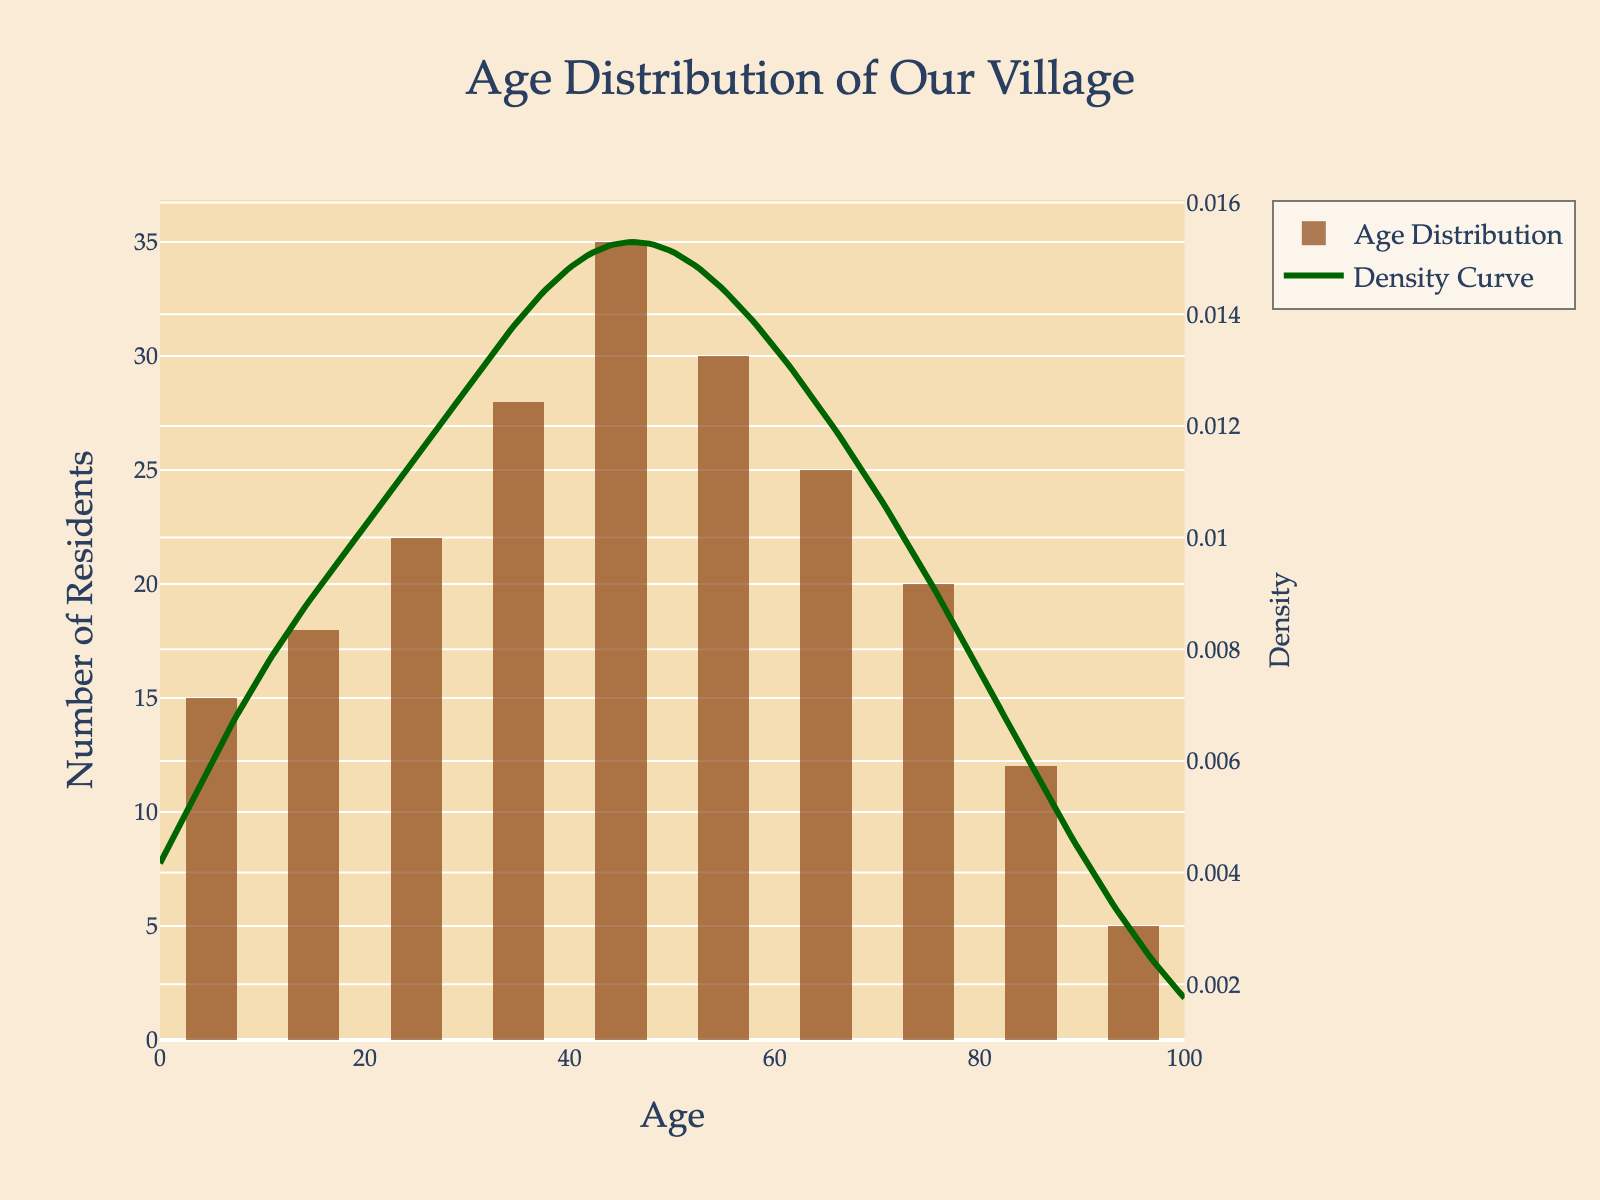what is the title of the plot? The title is prominently displayed at the top of the plot. It reads "Age Distribution of Our Village".
Answer: Age Distribution of Our Village What is the age group with the highest number of residents? The age groups are represented by bars, with the height indicating the count. The 40-49 age group has the tallest bar.
Answer: 40-49 How many residents are there in the 70-79 age group? The bar representing the 70-79 age group reaches the 20-mark on the y-axis, indicating there are 20 residents in this group.
Answer: 20 What is the trend observed from the 0-9 age group to the 40-49 age group? From the histogram, the bars representing the number of residents increase in height from 0-9 to 40-49. This indicates a rising trend or increasing number of residents with age, up to 49.
Answer: Increasing Which age group shows a noticeable decline in the number of residents after 50-59? The bars for age groups 60-69, 70-79, and 80-89 consecutively decrease in height, shown by the histogram, indicating fewer residents as age increases past 59.
Answer: 60-69 and beyond What is visible at the peaks of the KDE (density curve)? The KDE (density curve) has two noticeable peaks on the plot. By observing the x-axis values at these points, peaks are around the 35 and 45 age groups, representing higher density or concentration of the population in those ages.
Answer: Around 35 and 45 What are the colors used for the histogram and the density curve? The histogram bars are in a brown shade, and the density curve line is green, which helps in differentiating the two elements visually.
Answer: Brown for histogram, green for density curve Which age group has the fewest residents? By checking the histogram, the bar for the age group "90+" is the shortest, indicating the smallest number of residents.
Answer: 90+ Is there a secondary y-axis? If so, what does it measure? Yes, the plot has a secondary y-axis on the right, indicated by the KDE (density curve). It measures density, explaining the distribution of residents across age groups.
Answer: Density What does the density curve indicate about age distribution around 35 and 45? The peaks in the KDE around these age values indicate that a higher density of village residents falls into these age ranges, meaning many people in the village are in their mid-30s to mid-40s.
Answer: Higher density around 35 and 45 